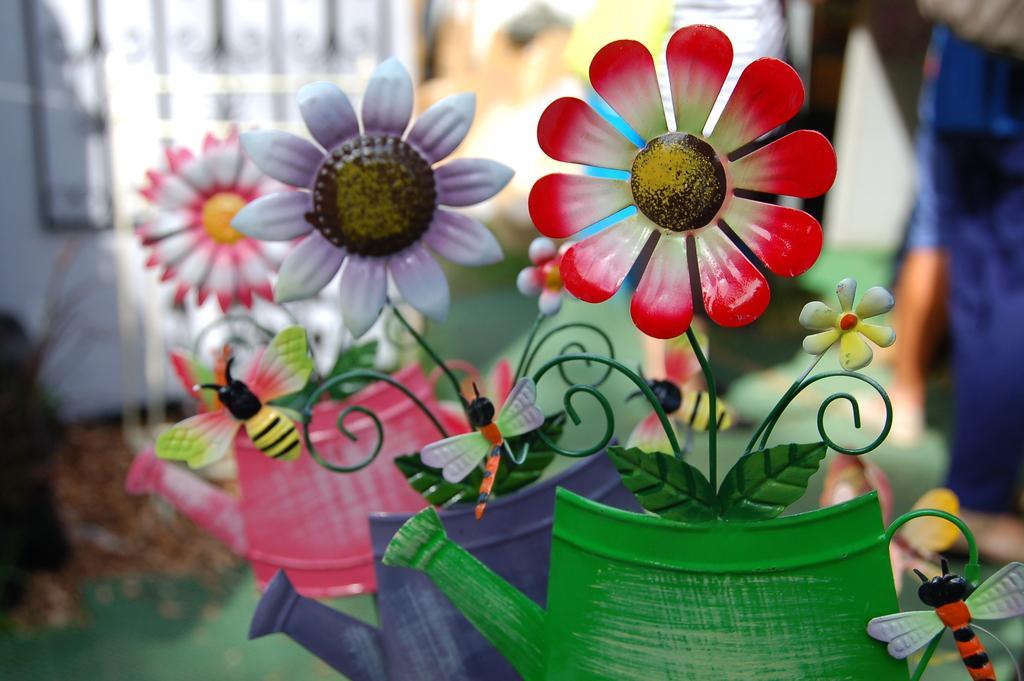How would you summarize this image in a sentence or two? In this image I can see few flowers in red,white,purple and green color. I can see blurred background. I can see few water cans. 